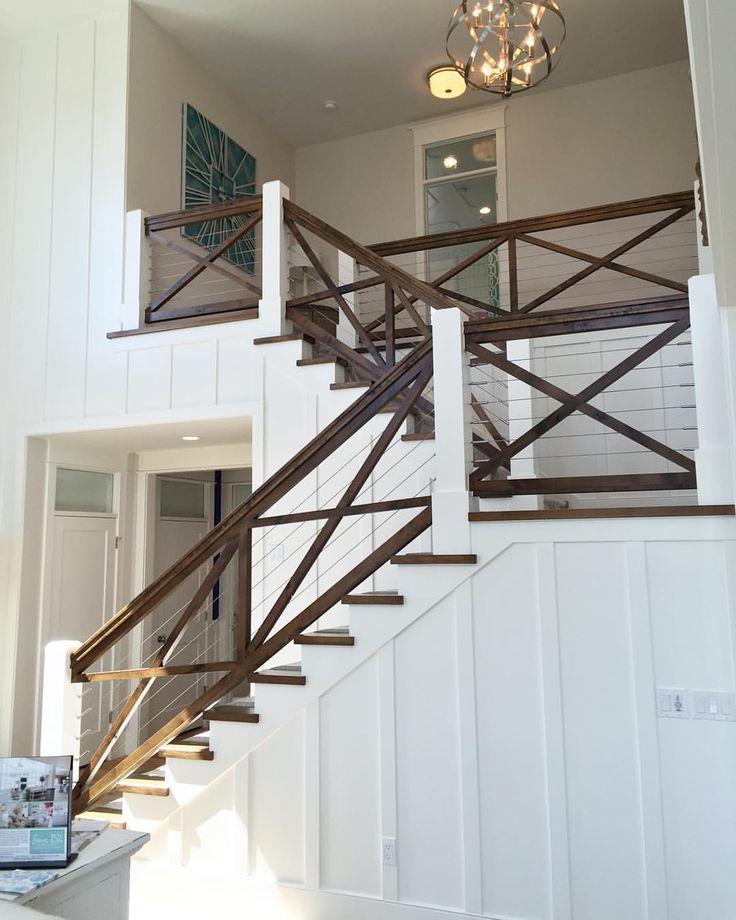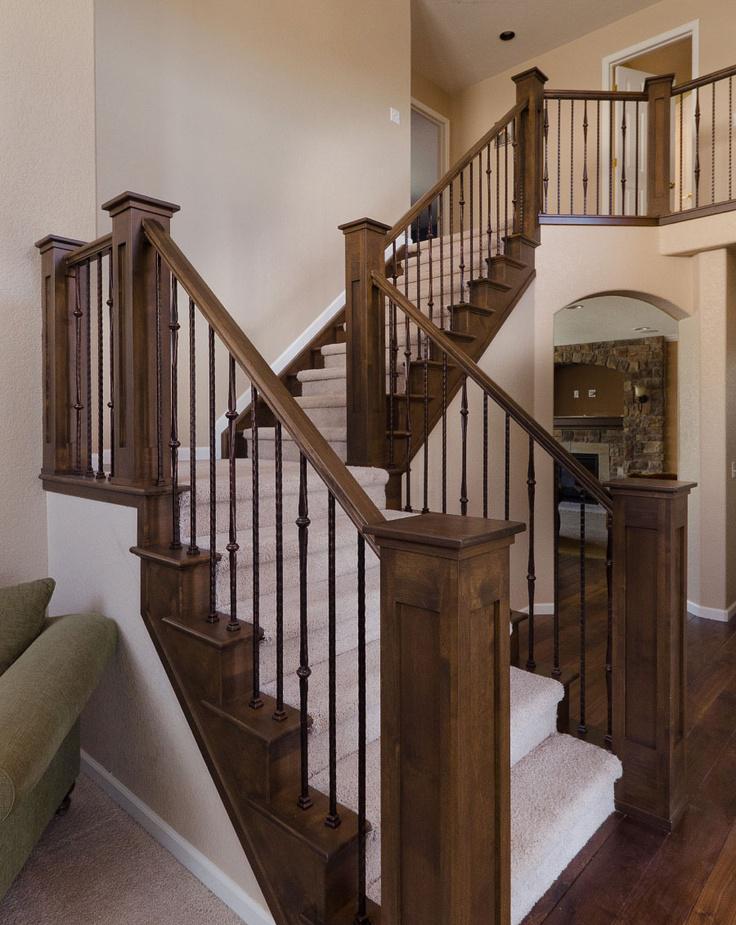The first image is the image on the left, the second image is the image on the right. For the images shown, is this caption "At least one of the lights is a pendant-style light hanging from the ceiling." true? Answer yes or no. Yes. 